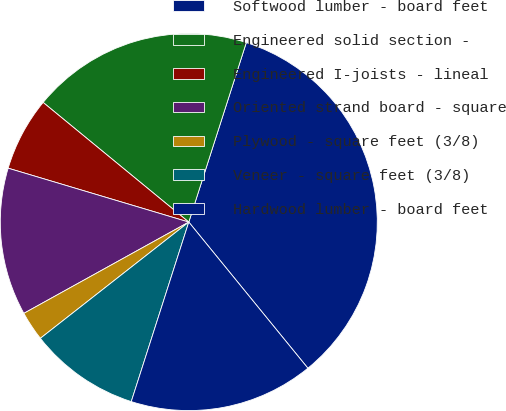<chart> <loc_0><loc_0><loc_500><loc_500><pie_chart><fcel>Softwood lumber - board feet<fcel>Engineered solid section -<fcel>Engineered I-joists - lineal<fcel>Oriented strand board - square<fcel>Plywood - square feet (3/8)<fcel>Veneer - square feet (3/8)<fcel>Hardwood lumber - board feet<nl><fcel>34.18%<fcel>18.99%<fcel>6.33%<fcel>12.66%<fcel>2.53%<fcel>9.49%<fcel>15.82%<nl></chart> 